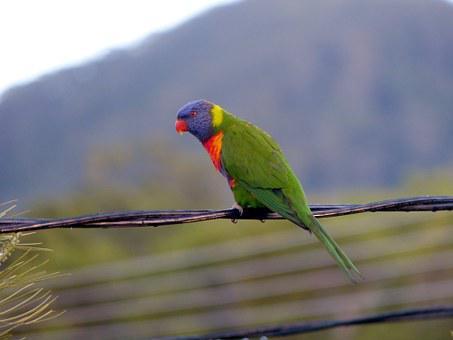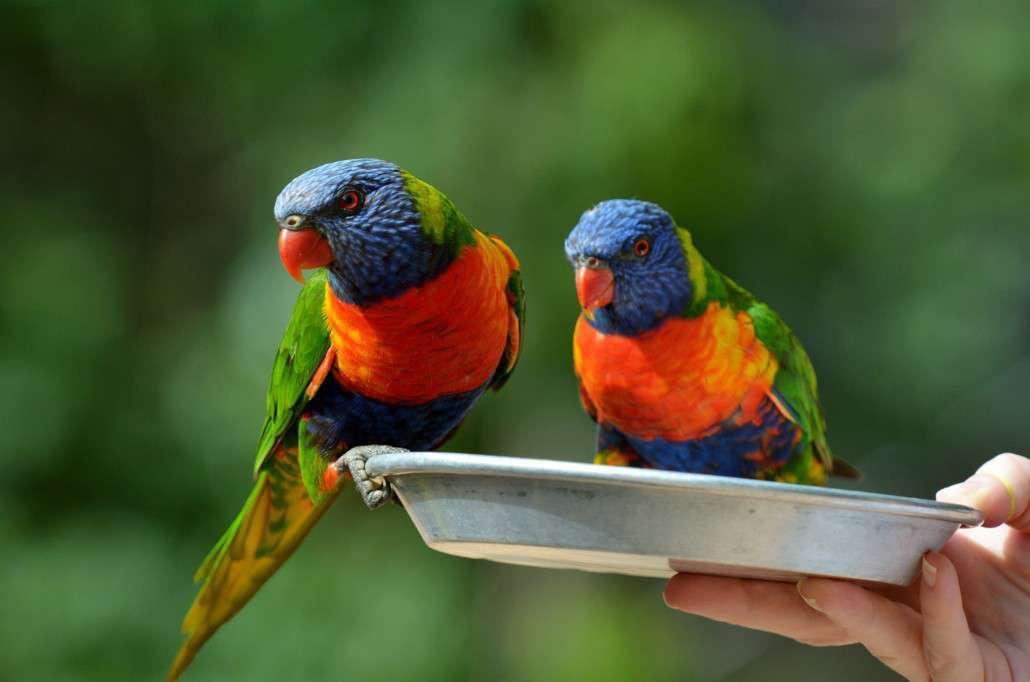The first image is the image on the left, the second image is the image on the right. Evaluate the accuracy of this statement regarding the images: "All of the birds are perched with their breast turned toward the camera.". Is it true? Answer yes or no. No. 